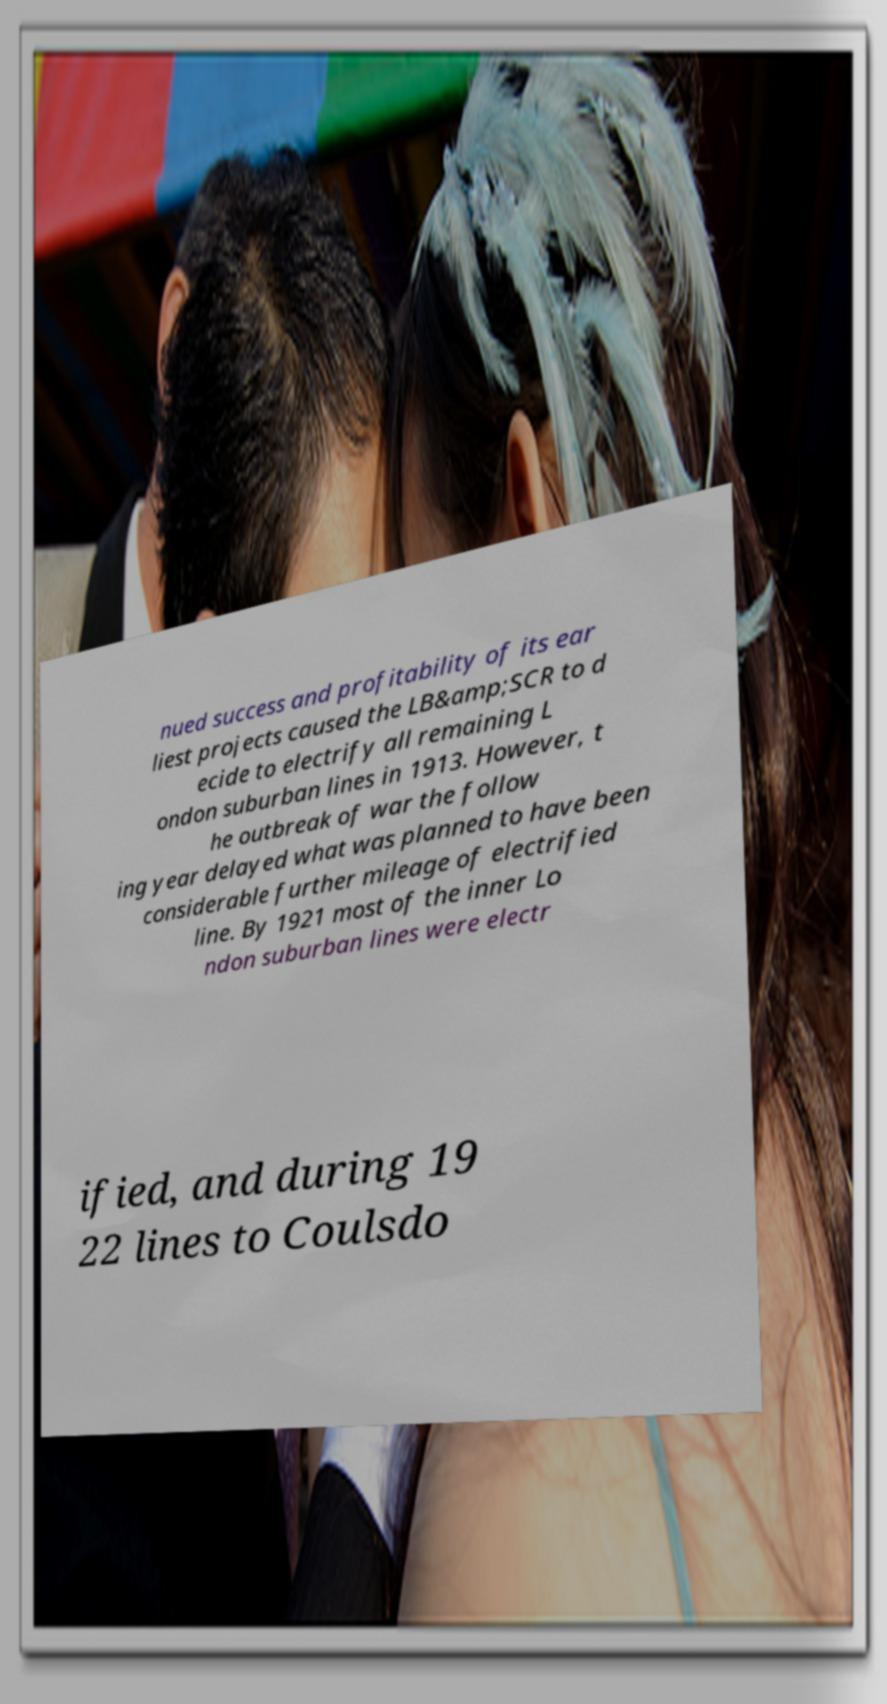Please identify and transcribe the text found in this image. nued success and profitability of its ear liest projects caused the LB&amp;SCR to d ecide to electrify all remaining L ondon suburban lines in 1913. However, t he outbreak of war the follow ing year delayed what was planned to have been considerable further mileage of electrified line. By 1921 most of the inner Lo ndon suburban lines were electr ified, and during 19 22 lines to Coulsdo 